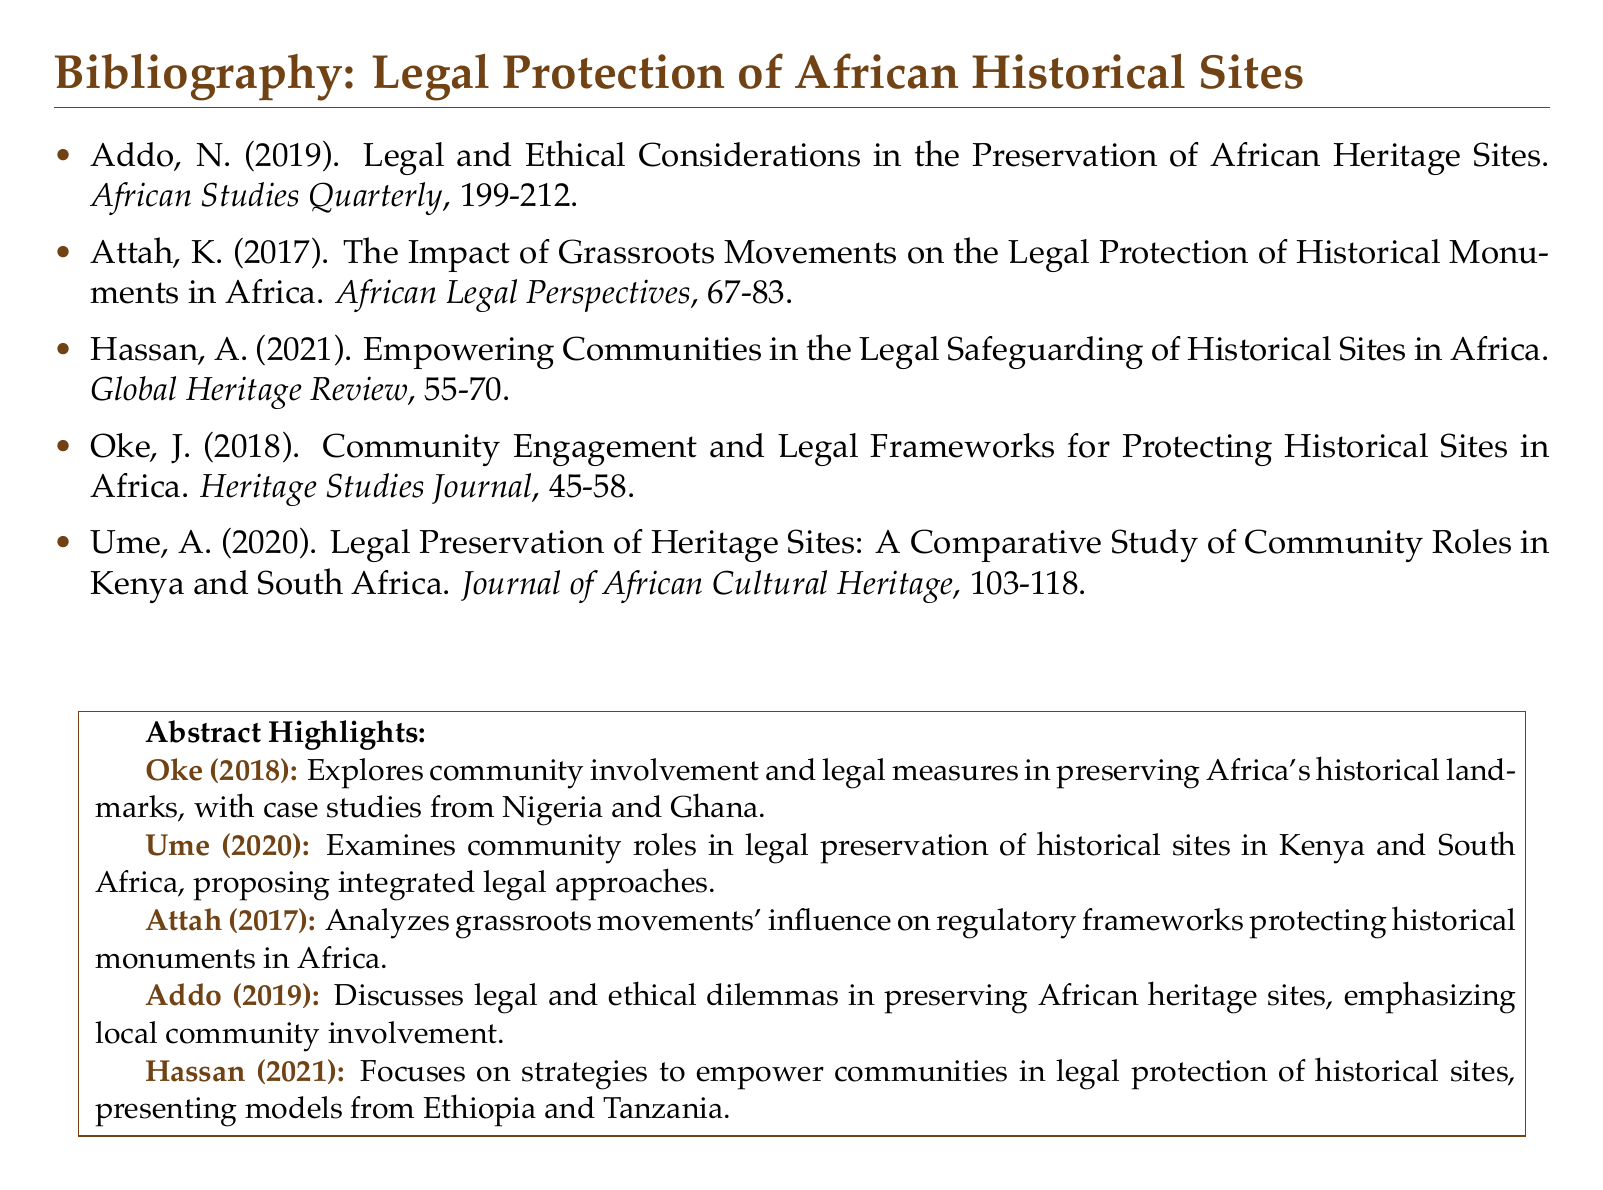What is the title of Addo's work? The title is found in the citation for Addo, which discusses legal and ethical considerations.
Answer: Legal and Ethical Considerations in the Preservation of African Heritage Sites Who authored the paper on grassroots movements? This information is obtained from the citation of the relevant work, which identifies the author.
Answer: Attah In what year was the paper by Hassan published? The year of publication is included in the citation for Hassan's article on community empowerment.
Answer: 2021 What journal published Oke's work? The journal name is specified in the citation for Oke's paper on community engagement.
Answer: Heritage Studies Journal Which countries are compared in Ume's study? The countries are mentioned in the title of Ume's work on legal preservation.
Answer: Kenya and South Africa What is the primary focus of Hassan's article? The focus is summarized in the title describing the aim of empowering communities.
Answer: Empowering Communities in the Legal Safeguarding of Historical Sites in Africa What type of document is this? This document is characterized by its content and structure, which includes citations regarding a specific topic.
Answer: Bibliography How many articles are listed in the bibliography? The total number of articles is determined by counting the entries in the bibliography section.
Answer: Five 